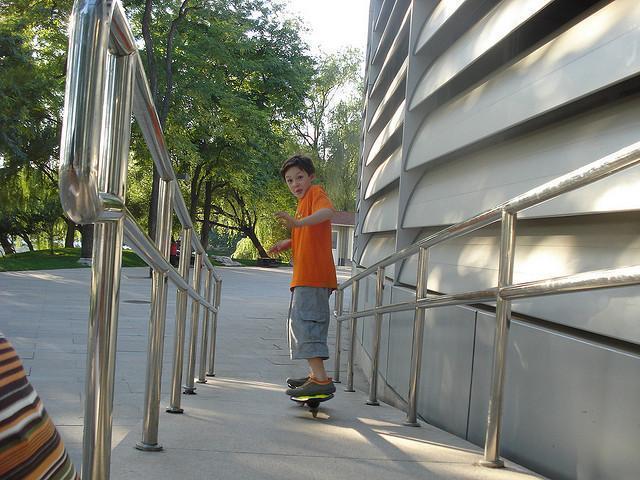What group of people is the ramp here constructed for?
Pick the right solution, then justify: 'Answer: answer
Rationale: rationale.'
Options: Handicapped people, merchants, bikers, singers. Answer: handicapped people.
Rationale: There are no stairs. a wheelchair can roll down the ramp easily. people with disabilities ride in wheelchairs. 